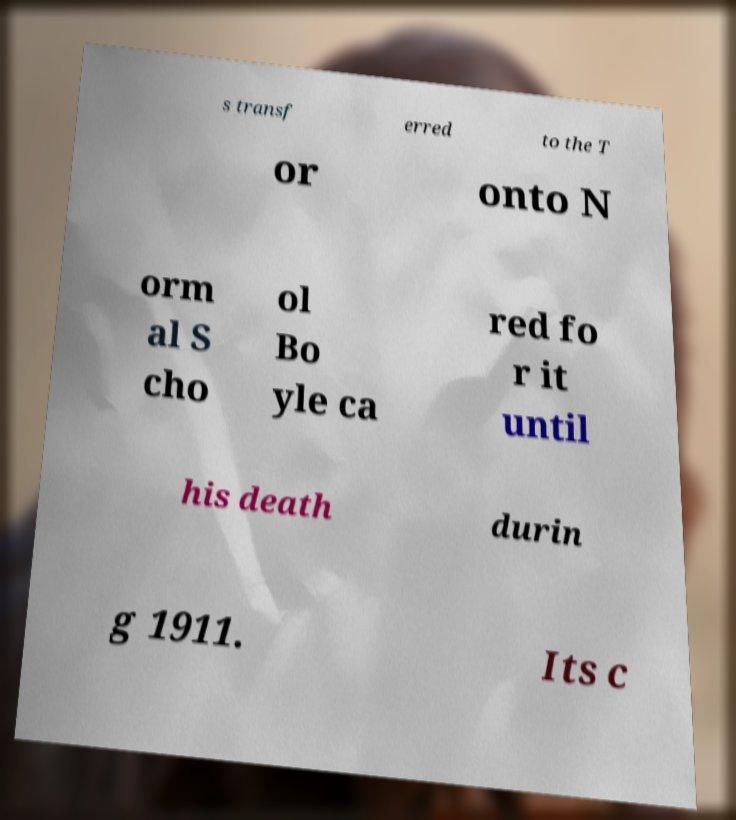Can you accurately transcribe the text from the provided image for me? s transf erred to the T or onto N orm al S cho ol Bo yle ca red fo r it until his death durin g 1911. Its c 